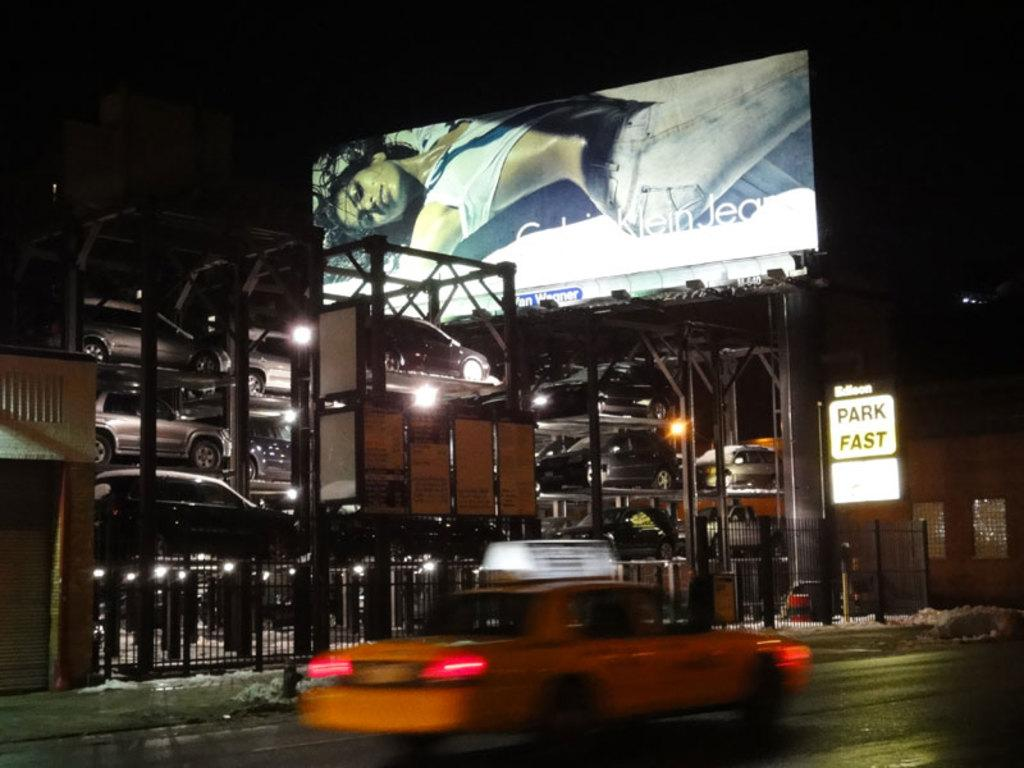<image>
Relay a brief, clear account of the picture shown. The billboard above the parking garage is advertising Calvin Klein jeans. 